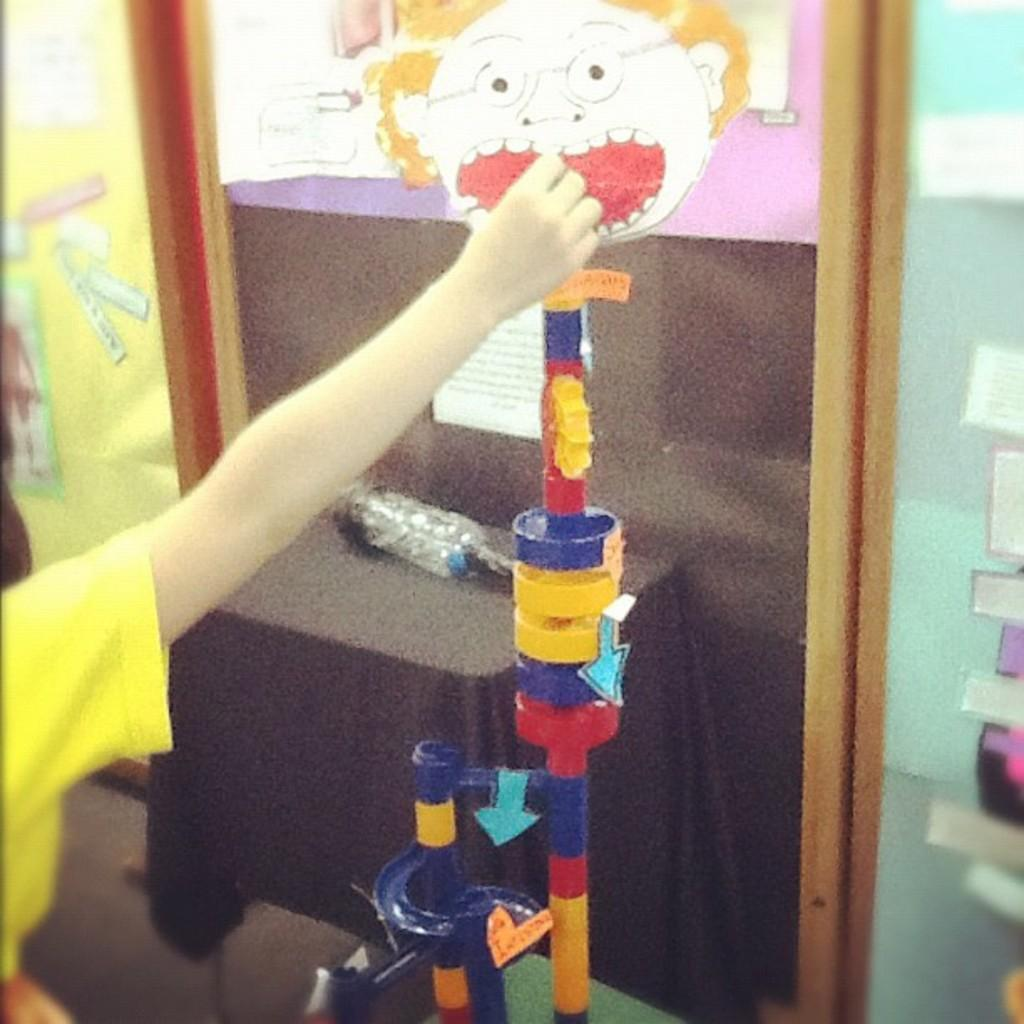What type of object can be seen in the image? There is a toy in the image. What is the other object visible in the image? There is a water bottle in the image. Whose hand is visible in the image? A person's hand is visible in the image. What type of war is being discussed in the image? There is no discussion of war in the image; it features a toy, a water bottle, and a person's hand. What type of secretary is present in the image? There is no secretary present in the image. 